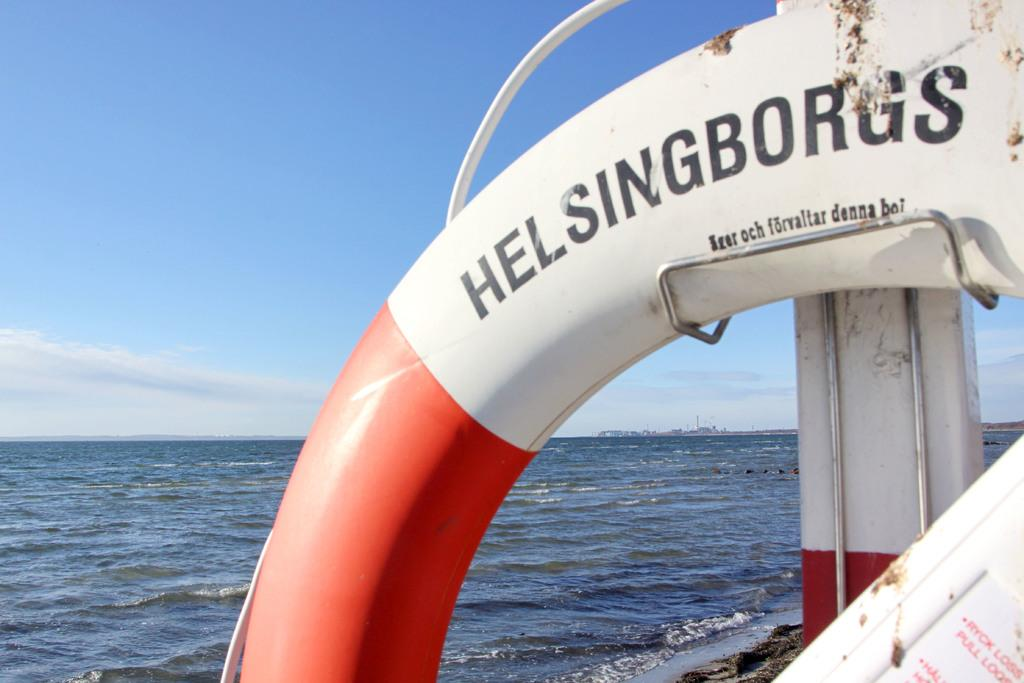What is the main subject of the image? There is an object in the image. Where is the object located in relation to the beach? The beach is at the bottom of the image. What can be seen in the sky in the image? The sky is visible at the top of the image. How does the object in the image help with coughing? The object in the image does not have any apparent function related to coughing, as it is not a medical device or related to health. 